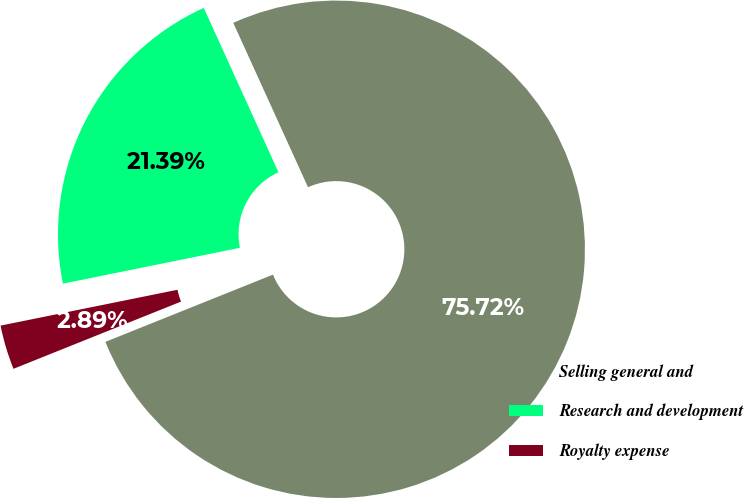Convert chart to OTSL. <chart><loc_0><loc_0><loc_500><loc_500><pie_chart><fcel>Selling general and<fcel>Research and development<fcel>Royalty expense<nl><fcel>75.72%<fcel>21.39%<fcel>2.89%<nl></chart> 